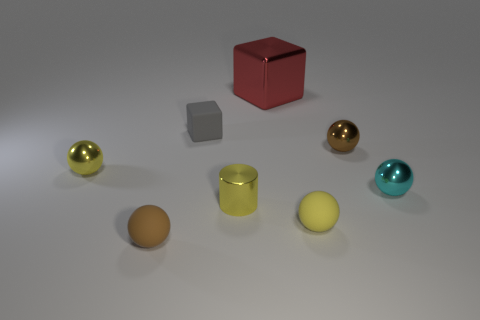Subtract 2 spheres. How many spheres are left? 3 Subtract all cyan balls. How many balls are left? 4 Subtract all yellow matte spheres. How many spheres are left? 4 Subtract all gray balls. Subtract all brown cylinders. How many balls are left? 5 Add 1 small metallic cylinders. How many objects exist? 9 Subtract all cylinders. How many objects are left? 7 Add 3 tiny blue spheres. How many tiny blue spheres exist? 3 Subtract 0 red cylinders. How many objects are left? 8 Subtract all yellow cubes. Subtract all tiny yellow metal spheres. How many objects are left? 7 Add 3 large objects. How many large objects are left? 4 